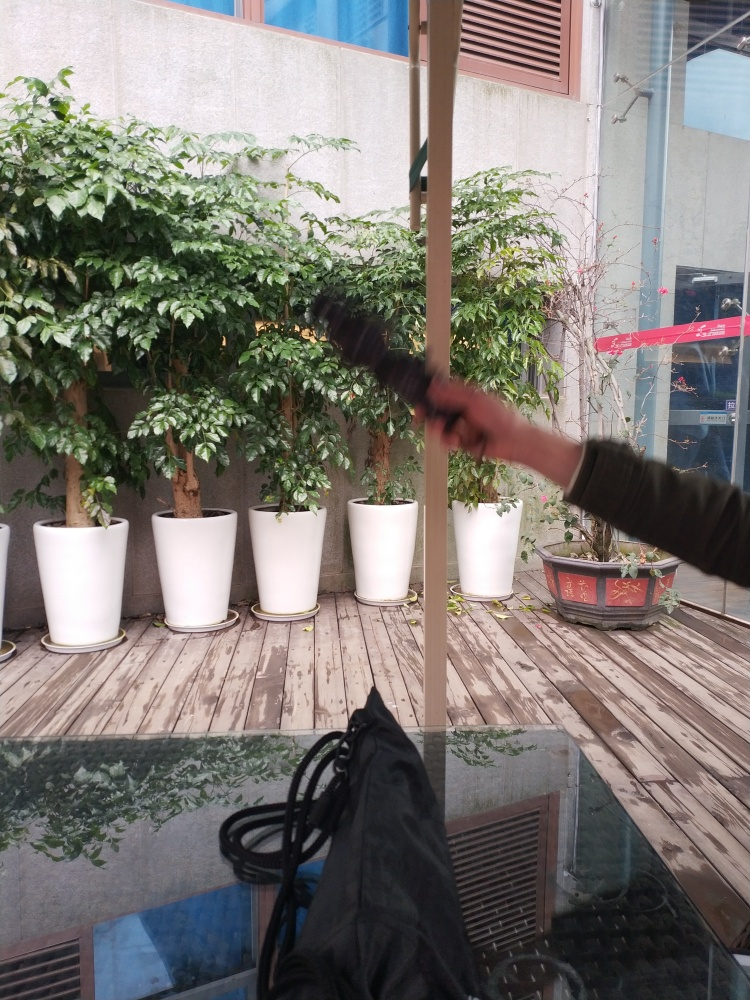Are there any focusing issues in the image? The clarity of the image is generally good, with the plants and pots in the background in sharp focus. However, there is a motion blur on the object in the foreground, perhaps a hand or an object in motion, indicating a small focusing issue with this element of the photograph. So, while the background is clear, the blurred element suggests a slight imperfection in focus. 